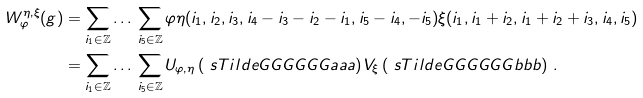<formula> <loc_0><loc_0><loc_500><loc_500>W _ { \varphi } ^ { \eta , \xi } ( g ) & = \sum _ { i _ { 1 } \in \mathbb { Z } } \dots \, \sum _ { i _ { 5 } \in \mathbb { Z } } \varphi \eta ( i _ { 1 } , i _ { 2 } , i _ { 3 } , i _ { 4 } - i _ { 3 } - i _ { 2 } - i _ { 1 } , i _ { 5 } - i _ { 4 } , - i _ { 5 } ) \xi ( i _ { 1 } , i _ { 1 } + i _ { 2 } , i _ { 1 } + i _ { 2 } + i _ { 3 } , i _ { 4 } , i _ { 5 } ) \\ & = \sum _ { i _ { 1 } \in \mathbb { Z } } \dots \, \sum _ { i _ { 5 } \in \mathbb { Z } } U _ { \varphi , \eta } \left ( \ s T i l d e G G G G G G a a a \right ) V _ { \xi } \left ( \ s T i l d e G G G G G G b b b \right ) \, .</formula> 